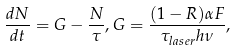<formula> <loc_0><loc_0><loc_500><loc_500>\frac { d N } { d t } = G - \frac { N } { \tau } , G = \frac { ( 1 - R ) \alpha F } { \tau _ { l a s e r } h \nu } ,</formula> 